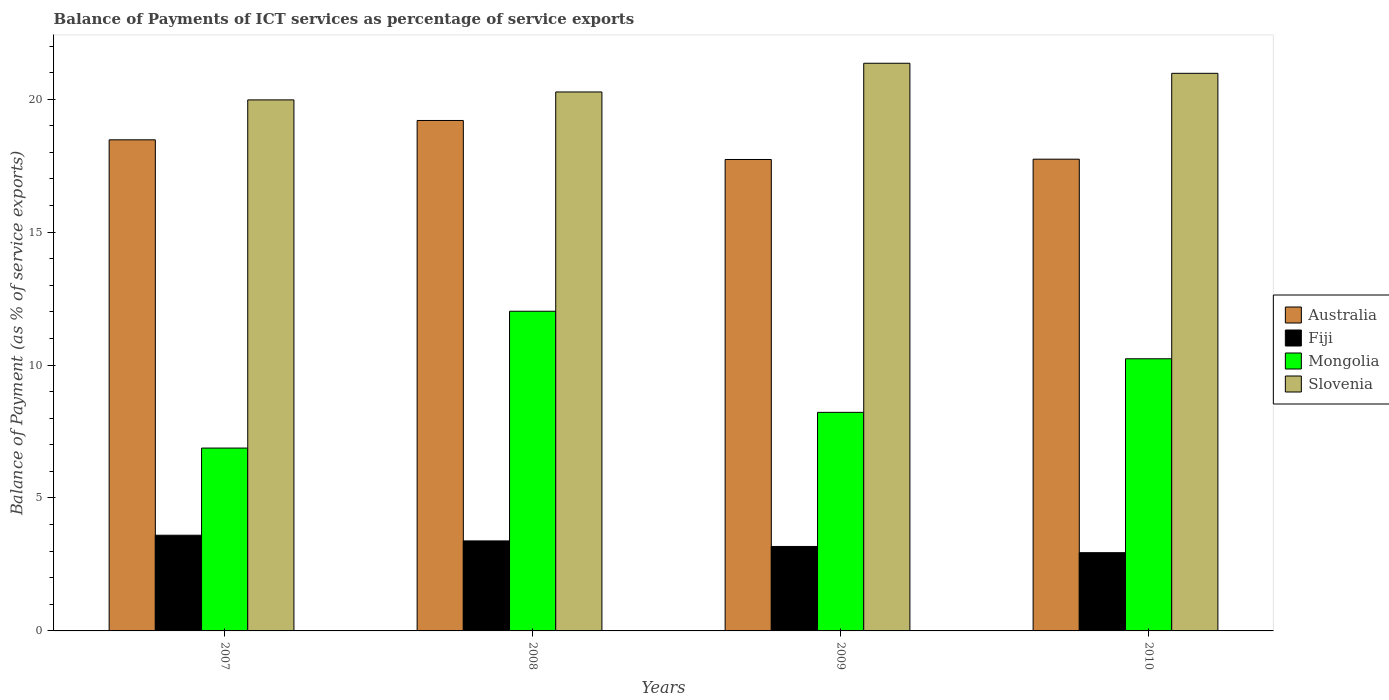How many different coloured bars are there?
Offer a very short reply. 4. Are the number of bars on each tick of the X-axis equal?
Your answer should be very brief. Yes. How many bars are there on the 2nd tick from the left?
Give a very brief answer. 4. How many bars are there on the 2nd tick from the right?
Provide a short and direct response. 4. In how many cases, is the number of bars for a given year not equal to the number of legend labels?
Make the answer very short. 0. What is the balance of payments of ICT services in Fiji in 2010?
Your answer should be very brief. 2.94. Across all years, what is the maximum balance of payments of ICT services in Slovenia?
Keep it short and to the point. 21.35. Across all years, what is the minimum balance of payments of ICT services in Slovenia?
Keep it short and to the point. 19.97. In which year was the balance of payments of ICT services in Australia maximum?
Offer a very short reply. 2008. What is the total balance of payments of ICT services in Mongolia in the graph?
Keep it short and to the point. 37.36. What is the difference between the balance of payments of ICT services in Fiji in 2007 and that in 2010?
Offer a terse response. 0.66. What is the difference between the balance of payments of ICT services in Slovenia in 2008 and the balance of payments of ICT services in Australia in 2010?
Provide a short and direct response. 2.53. What is the average balance of payments of ICT services in Fiji per year?
Your answer should be very brief. 3.28. In the year 2010, what is the difference between the balance of payments of ICT services in Australia and balance of payments of ICT services in Mongolia?
Offer a terse response. 7.51. What is the ratio of the balance of payments of ICT services in Mongolia in 2008 to that in 2010?
Give a very brief answer. 1.17. What is the difference between the highest and the second highest balance of payments of ICT services in Slovenia?
Provide a short and direct response. 0.38. What is the difference between the highest and the lowest balance of payments of ICT services in Fiji?
Offer a very short reply. 0.66. Is the sum of the balance of payments of ICT services in Mongolia in 2008 and 2009 greater than the maximum balance of payments of ICT services in Fiji across all years?
Offer a terse response. Yes. Is it the case that in every year, the sum of the balance of payments of ICT services in Mongolia and balance of payments of ICT services in Fiji is greater than the sum of balance of payments of ICT services in Australia and balance of payments of ICT services in Slovenia?
Offer a terse response. No. What does the 2nd bar from the left in 2007 represents?
Make the answer very short. Fiji. What does the 3rd bar from the right in 2010 represents?
Provide a short and direct response. Fiji. Is it the case that in every year, the sum of the balance of payments of ICT services in Slovenia and balance of payments of ICT services in Fiji is greater than the balance of payments of ICT services in Australia?
Your answer should be very brief. Yes. Are all the bars in the graph horizontal?
Give a very brief answer. No. Does the graph contain any zero values?
Keep it short and to the point. No. What is the title of the graph?
Provide a succinct answer. Balance of Payments of ICT services as percentage of service exports. Does "Afghanistan" appear as one of the legend labels in the graph?
Offer a terse response. No. What is the label or title of the X-axis?
Make the answer very short. Years. What is the label or title of the Y-axis?
Ensure brevity in your answer.  Balance of Payment (as % of service exports). What is the Balance of Payment (as % of service exports) in Australia in 2007?
Keep it short and to the point. 18.47. What is the Balance of Payment (as % of service exports) in Fiji in 2007?
Keep it short and to the point. 3.6. What is the Balance of Payment (as % of service exports) of Mongolia in 2007?
Provide a short and direct response. 6.88. What is the Balance of Payment (as % of service exports) of Slovenia in 2007?
Keep it short and to the point. 19.97. What is the Balance of Payment (as % of service exports) in Australia in 2008?
Offer a terse response. 19.2. What is the Balance of Payment (as % of service exports) in Fiji in 2008?
Keep it short and to the point. 3.39. What is the Balance of Payment (as % of service exports) in Mongolia in 2008?
Your answer should be compact. 12.02. What is the Balance of Payment (as % of service exports) of Slovenia in 2008?
Provide a succinct answer. 20.27. What is the Balance of Payment (as % of service exports) of Australia in 2009?
Your answer should be compact. 17.73. What is the Balance of Payment (as % of service exports) of Fiji in 2009?
Offer a terse response. 3.18. What is the Balance of Payment (as % of service exports) in Mongolia in 2009?
Your response must be concise. 8.22. What is the Balance of Payment (as % of service exports) in Slovenia in 2009?
Provide a short and direct response. 21.35. What is the Balance of Payment (as % of service exports) in Australia in 2010?
Your answer should be compact. 17.74. What is the Balance of Payment (as % of service exports) of Fiji in 2010?
Give a very brief answer. 2.94. What is the Balance of Payment (as % of service exports) of Mongolia in 2010?
Your response must be concise. 10.24. What is the Balance of Payment (as % of service exports) of Slovenia in 2010?
Ensure brevity in your answer.  20.97. Across all years, what is the maximum Balance of Payment (as % of service exports) in Australia?
Make the answer very short. 19.2. Across all years, what is the maximum Balance of Payment (as % of service exports) of Fiji?
Offer a terse response. 3.6. Across all years, what is the maximum Balance of Payment (as % of service exports) in Mongolia?
Offer a terse response. 12.02. Across all years, what is the maximum Balance of Payment (as % of service exports) of Slovenia?
Your response must be concise. 21.35. Across all years, what is the minimum Balance of Payment (as % of service exports) in Australia?
Offer a terse response. 17.73. Across all years, what is the minimum Balance of Payment (as % of service exports) in Fiji?
Ensure brevity in your answer.  2.94. Across all years, what is the minimum Balance of Payment (as % of service exports) in Mongolia?
Provide a succinct answer. 6.88. Across all years, what is the minimum Balance of Payment (as % of service exports) of Slovenia?
Ensure brevity in your answer.  19.97. What is the total Balance of Payment (as % of service exports) of Australia in the graph?
Keep it short and to the point. 73.15. What is the total Balance of Payment (as % of service exports) in Fiji in the graph?
Provide a short and direct response. 13.1. What is the total Balance of Payment (as % of service exports) of Mongolia in the graph?
Give a very brief answer. 37.36. What is the total Balance of Payment (as % of service exports) of Slovenia in the graph?
Offer a terse response. 82.57. What is the difference between the Balance of Payment (as % of service exports) in Australia in 2007 and that in 2008?
Your answer should be very brief. -0.73. What is the difference between the Balance of Payment (as % of service exports) in Fiji in 2007 and that in 2008?
Your response must be concise. 0.21. What is the difference between the Balance of Payment (as % of service exports) in Mongolia in 2007 and that in 2008?
Provide a short and direct response. -5.15. What is the difference between the Balance of Payment (as % of service exports) in Slovenia in 2007 and that in 2008?
Your answer should be very brief. -0.3. What is the difference between the Balance of Payment (as % of service exports) of Australia in 2007 and that in 2009?
Your answer should be very brief. 0.74. What is the difference between the Balance of Payment (as % of service exports) in Fiji in 2007 and that in 2009?
Offer a very short reply. 0.42. What is the difference between the Balance of Payment (as % of service exports) in Mongolia in 2007 and that in 2009?
Offer a terse response. -1.34. What is the difference between the Balance of Payment (as % of service exports) in Slovenia in 2007 and that in 2009?
Your answer should be very brief. -1.38. What is the difference between the Balance of Payment (as % of service exports) in Australia in 2007 and that in 2010?
Keep it short and to the point. 0.73. What is the difference between the Balance of Payment (as % of service exports) in Fiji in 2007 and that in 2010?
Provide a short and direct response. 0.66. What is the difference between the Balance of Payment (as % of service exports) in Mongolia in 2007 and that in 2010?
Provide a short and direct response. -3.36. What is the difference between the Balance of Payment (as % of service exports) of Slovenia in 2007 and that in 2010?
Make the answer very short. -1. What is the difference between the Balance of Payment (as % of service exports) of Australia in 2008 and that in 2009?
Offer a terse response. 1.47. What is the difference between the Balance of Payment (as % of service exports) in Fiji in 2008 and that in 2009?
Your answer should be very brief. 0.21. What is the difference between the Balance of Payment (as % of service exports) of Mongolia in 2008 and that in 2009?
Ensure brevity in your answer.  3.8. What is the difference between the Balance of Payment (as % of service exports) of Slovenia in 2008 and that in 2009?
Keep it short and to the point. -1.08. What is the difference between the Balance of Payment (as % of service exports) of Australia in 2008 and that in 2010?
Offer a very short reply. 1.46. What is the difference between the Balance of Payment (as % of service exports) in Fiji in 2008 and that in 2010?
Provide a short and direct response. 0.44. What is the difference between the Balance of Payment (as % of service exports) in Mongolia in 2008 and that in 2010?
Your answer should be very brief. 1.79. What is the difference between the Balance of Payment (as % of service exports) in Slovenia in 2008 and that in 2010?
Provide a succinct answer. -0.7. What is the difference between the Balance of Payment (as % of service exports) of Australia in 2009 and that in 2010?
Your answer should be very brief. -0.01. What is the difference between the Balance of Payment (as % of service exports) in Fiji in 2009 and that in 2010?
Provide a short and direct response. 0.23. What is the difference between the Balance of Payment (as % of service exports) of Mongolia in 2009 and that in 2010?
Offer a terse response. -2.02. What is the difference between the Balance of Payment (as % of service exports) in Slovenia in 2009 and that in 2010?
Provide a succinct answer. 0.38. What is the difference between the Balance of Payment (as % of service exports) of Australia in 2007 and the Balance of Payment (as % of service exports) of Fiji in 2008?
Provide a short and direct response. 15.09. What is the difference between the Balance of Payment (as % of service exports) in Australia in 2007 and the Balance of Payment (as % of service exports) in Mongolia in 2008?
Your response must be concise. 6.45. What is the difference between the Balance of Payment (as % of service exports) in Australia in 2007 and the Balance of Payment (as % of service exports) in Slovenia in 2008?
Ensure brevity in your answer.  -1.8. What is the difference between the Balance of Payment (as % of service exports) in Fiji in 2007 and the Balance of Payment (as % of service exports) in Mongolia in 2008?
Give a very brief answer. -8.43. What is the difference between the Balance of Payment (as % of service exports) in Fiji in 2007 and the Balance of Payment (as % of service exports) in Slovenia in 2008?
Your answer should be compact. -16.67. What is the difference between the Balance of Payment (as % of service exports) of Mongolia in 2007 and the Balance of Payment (as % of service exports) of Slovenia in 2008?
Provide a succinct answer. -13.39. What is the difference between the Balance of Payment (as % of service exports) in Australia in 2007 and the Balance of Payment (as % of service exports) in Fiji in 2009?
Provide a short and direct response. 15.29. What is the difference between the Balance of Payment (as % of service exports) of Australia in 2007 and the Balance of Payment (as % of service exports) of Mongolia in 2009?
Ensure brevity in your answer.  10.25. What is the difference between the Balance of Payment (as % of service exports) in Australia in 2007 and the Balance of Payment (as % of service exports) in Slovenia in 2009?
Offer a very short reply. -2.88. What is the difference between the Balance of Payment (as % of service exports) of Fiji in 2007 and the Balance of Payment (as % of service exports) of Mongolia in 2009?
Your answer should be compact. -4.62. What is the difference between the Balance of Payment (as % of service exports) in Fiji in 2007 and the Balance of Payment (as % of service exports) in Slovenia in 2009?
Keep it short and to the point. -17.75. What is the difference between the Balance of Payment (as % of service exports) in Mongolia in 2007 and the Balance of Payment (as % of service exports) in Slovenia in 2009?
Offer a terse response. -14.47. What is the difference between the Balance of Payment (as % of service exports) in Australia in 2007 and the Balance of Payment (as % of service exports) in Fiji in 2010?
Ensure brevity in your answer.  15.53. What is the difference between the Balance of Payment (as % of service exports) of Australia in 2007 and the Balance of Payment (as % of service exports) of Mongolia in 2010?
Ensure brevity in your answer.  8.24. What is the difference between the Balance of Payment (as % of service exports) of Australia in 2007 and the Balance of Payment (as % of service exports) of Slovenia in 2010?
Your response must be concise. -2.5. What is the difference between the Balance of Payment (as % of service exports) of Fiji in 2007 and the Balance of Payment (as % of service exports) of Mongolia in 2010?
Keep it short and to the point. -6.64. What is the difference between the Balance of Payment (as % of service exports) in Fiji in 2007 and the Balance of Payment (as % of service exports) in Slovenia in 2010?
Offer a very short reply. -17.37. What is the difference between the Balance of Payment (as % of service exports) of Mongolia in 2007 and the Balance of Payment (as % of service exports) of Slovenia in 2010?
Offer a very short reply. -14.1. What is the difference between the Balance of Payment (as % of service exports) in Australia in 2008 and the Balance of Payment (as % of service exports) in Fiji in 2009?
Provide a short and direct response. 16.02. What is the difference between the Balance of Payment (as % of service exports) in Australia in 2008 and the Balance of Payment (as % of service exports) in Mongolia in 2009?
Your answer should be very brief. 10.98. What is the difference between the Balance of Payment (as % of service exports) in Australia in 2008 and the Balance of Payment (as % of service exports) in Slovenia in 2009?
Ensure brevity in your answer.  -2.15. What is the difference between the Balance of Payment (as % of service exports) in Fiji in 2008 and the Balance of Payment (as % of service exports) in Mongolia in 2009?
Give a very brief answer. -4.84. What is the difference between the Balance of Payment (as % of service exports) in Fiji in 2008 and the Balance of Payment (as % of service exports) in Slovenia in 2009?
Ensure brevity in your answer.  -17.97. What is the difference between the Balance of Payment (as % of service exports) in Mongolia in 2008 and the Balance of Payment (as % of service exports) in Slovenia in 2009?
Keep it short and to the point. -9.33. What is the difference between the Balance of Payment (as % of service exports) of Australia in 2008 and the Balance of Payment (as % of service exports) of Fiji in 2010?
Give a very brief answer. 16.26. What is the difference between the Balance of Payment (as % of service exports) in Australia in 2008 and the Balance of Payment (as % of service exports) in Mongolia in 2010?
Make the answer very short. 8.96. What is the difference between the Balance of Payment (as % of service exports) of Australia in 2008 and the Balance of Payment (as % of service exports) of Slovenia in 2010?
Make the answer very short. -1.77. What is the difference between the Balance of Payment (as % of service exports) in Fiji in 2008 and the Balance of Payment (as % of service exports) in Mongolia in 2010?
Your answer should be very brief. -6.85. What is the difference between the Balance of Payment (as % of service exports) in Fiji in 2008 and the Balance of Payment (as % of service exports) in Slovenia in 2010?
Your answer should be very brief. -17.59. What is the difference between the Balance of Payment (as % of service exports) in Mongolia in 2008 and the Balance of Payment (as % of service exports) in Slovenia in 2010?
Ensure brevity in your answer.  -8.95. What is the difference between the Balance of Payment (as % of service exports) in Australia in 2009 and the Balance of Payment (as % of service exports) in Fiji in 2010?
Give a very brief answer. 14.79. What is the difference between the Balance of Payment (as % of service exports) in Australia in 2009 and the Balance of Payment (as % of service exports) in Mongolia in 2010?
Provide a succinct answer. 7.5. What is the difference between the Balance of Payment (as % of service exports) of Australia in 2009 and the Balance of Payment (as % of service exports) of Slovenia in 2010?
Your response must be concise. -3.24. What is the difference between the Balance of Payment (as % of service exports) in Fiji in 2009 and the Balance of Payment (as % of service exports) in Mongolia in 2010?
Your answer should be very brief. -7.06. What is the difference between the Balance of Payment (as % of service exports) in Fiji in 2009 and the Balance of Payment (as % of service exports) in Slovenia in 2010?
Keep it short and to the point. -17.8. What is the difference between the Balance of Payment (as % of service exports) in Mongolia in 2009 and the Balance of Payment (as % of service exports) in Slovenia in 2010?
Give a very brief answer. -12.75. What is the average Balance of Payment (as % of service exports) of Australia per year?
Provide a short and direct response. 18.29. What is the average Balance of Payment (as % of service exports) in Fiji per year?
Keep it short and to the point. 3.28. What is the average Balance of Payment (as % of service exports) in Mongolia per year?
Ensure brevity in your answer.  9.34. What is the average Balance of Payment (as % of service exports) in Slovenia per year?
Offer a very short reply. 20.64. In the year 2007, what is the difference between the Balance of Payment (as % of service exports) of Australia and Balance of Payment (as % of service exports) of Fiji?
Offer a very short reply. 14.87. In the year 2007, what is the difference between the Balance of Payment (as % of service exports) of Australia and Balance of Payment (as % of service exports) of Mongolia?
Keep it short and to the point. 11.59. In the year 2007, what is the difference between the Balance of Payment (as % of service exports) of Australia and Balance of Payment (as % of service exports) of Slovenia?
Offer a very short reply. -1.5. In the year 2007, what is the difference between the Balance of Payment (as % of service exports) in Fiji and Balance of Payment (as % of service exports) in Mongolia?
Make the answer very short. -3.28. In the year 2007, what is the difference between the Balance of Payment (as % of service exports) in Fiji and Balance of Payment (as % of service exports) in Slovenia?
Offer a very short reply. -16.37. In the year 2007, what is the difference between the Balance of Payment (as % of service exports) in Mongolia and Balance of Payment (as % of service exports) in Slovenia?
Give a very brief answer. -13.1. In the year 2008, what is the difference between the Balance of Payment (as % of service exports) of Australia and Balance of Payment (as % of service exports) of Fiji?
Give a very brief answer. 15.81. In the year 2008, what is the difference between the Balance of Payment (as % of service exports) in Australia and Balance of Payment (as % of service exports) in Mongolia?
Your response must be concise. 7.18. In the year 2008, what is the difference between the Balance of Payment (as % of service exports) in Australia and Balance of Payment (as % of service exports) in Slovenia?
Give a very brief answer. -1.07. In the year 2008, what is the difference between the Balance of Payment (as % of service exports) of Fiji and Balance of Payment (as % of service exports) of Mongolia?
Provide a succinct answer. -8.64. In the year 2008, what is the difference between the Balance of Payment (as % of service exports) in Fiji and Balance of Payment (as % of service exports) in Slovenia?
Your answer should be compact. -16.89. In the year 2008, what is the difference between the Balance of Payment (as % of service exports) in Mongolia and Balance of Payment (as % of service exports) in Slovenia?
Keep it short and to the point. -8.25. In the year 2009, what is the difference between the Balance of Payment (as % of service exports) of Australia and Balance of Payment (as % of service exports) of Fiji?
Make the answer very short. 14.56. In the year 2009, what is the difference between the Balance of Payment (as % of service exports) of Australia and Balance of Payment (as % of service exports) of Mongolia?
Ensure brevity in your answer.  9.51. In the year 2009, what is the difference between the Balance of Payment (as % of service exports) in Australia and Balance of Payment (as % of service exports) in Slovenia?
Offer a very short reply. -3.62. In the year 2009, what is the difference between the Balance of Payment (as % of service exports) of Fiji and Balance of Payment (as % of service exports) of Mongolia?
Provide a short and direct response. -5.04. In the year 2009, what is the difference between the Balance of Payment (as % of service exports) of Fiji and Balance of Payment (as % of service exports) of Slovenia?
Your response must be concise. -18.17. In the year 2009, what is the difference between the Balance of Payment (as % of service exports) in Mongolia and Balance of Payment (as % of service exports) in Slovenia?
Your answer should be compact. -13.13. In the year 2010, what is the difference between the Balance of Payment (as % of service exports) of Australia and Balance of Payment (as % of service exports) of Fiji?
Your response must be concise. 14.8. In the year 2010, what is the difference between the Balance of Payment (as % of service exports) in Australia and Balance of Payment (as % of service exports) in Mongolia?
Keep it short and to the point. 7.51. In the year 2010, what is the difference between the Balance of Payment (as % of service exports) in Australia and Balance of Payment (as % of service exports) in Slovenia?
Offer a very short reply. -3.23. In the year 2010, what is the difference between the Balance of Payment (as % of service exports) of Fiji and Balance of Payment (as % of service exports) of Mongolia?
Offer a very short reply. -7.29. In the year 2010, what is the difference between the Balance of Payment (as % of service exports) of Fiji and Balance of Payment (as % of service exports) of Slovenia?
Give a very brief answer. -18.03. In the year 2010, what is the difference between the Balance of Payment (as % of service exports) in Mongolia and Balance of Payment (as % of service exports) in Slovenia?
Offer a very short reply. -10.74. What is the ratio of the Balance of Payment (as % of service exports) in Australia in 2007 to that in 2008?
Offer a terse response. 0.96. What is the ratio of the Balance of Payment (as % of service exports) in Fiji in 2007 to that in 2008?
Your answer should be compact. 1.06. What is the ratio of the Balance of Payment (as % of service exports) in Mongolia in 2007 to that in 2008?
Give a very brief answer. 0.57. What is the ratio of the Balance of Payment (as % of service exports) of Australia in 2007 to that in 2009?
Provide a succinct answer. 1.04. What is the ratio of the Balance of Payment (as % of service exports) in Fiji in 2007 to that in 2009?
Give a very brief answer. 1.13. What is the ratio of the Balance of Payment (as % of service exports) of Mongolia in 2007 to that in 2009?
Make the answer very short. 0.84. What is the ratio of the Balance of Payment (as % of service exports) of Slovenia in 2007 to that in 2009?
Provide a short and direct response. 0.94. What is the ratio of the Balance of Payment (as % of service exports) in Australia in 2007 to that in 2010?
Ensure brevity in your answer.  1.04. What is the ratio of the Balance of Payment (as % of service exports) in Fiji in 2007 to that in 2010?
Your response must be concise. 1.22. What is the ratio of the Balance of Payment (as % of service exports) of Mongolia in 2007 to that in 2010?
Offer a very short reply. 0.67. What is the ratio of the Balance of Payment (as % of service exports) in Slovenia in 2007 to that in 2010?
Your answer should be compact. 0.95. What is the ratio of the Balance of Payment (as % of service exports) in Australia in 2008 to that in 2009?
Make the answer very short. 1.08. What is the ratio of the Balance of Payment (as % of service exports) of Fiji in 2008 to that in 2009?
Make the answer very short. 1.07. What is the ratio of the Balance of Payment (as % of service exports) in Mongolia in 2008 to that in 2009?
Offer a very short reply. 1.46. What is the ratio of the Balance of Payment (as % of service exports) in Slovenia in 2008 to that in 2009?
Offer a very short reply. 0.95. What is the ratio of the Balance of Payment (as % of service exports) of Australia in 2008 to that in 2010?
Make the answer very short. 1.08. What is the ratio of the Balance of Payment (as % of service exports) in Fiji in 2008 to that in 2010?
Provide a short and direct response. 1.15. What is the ratio of the Balance of Payment (as % of service exports) of Mongolia in 2008 to that in 2010?
Provide a succinct answer. 1.17. What is the ratio of the Balance of Payment (as % of service exports) of Slovenia in 2008 to that in 2010?
Your response must be concise. 0.97. What is the ratio of the Balance of Payment (as % of service exports) of Fiji in 2009 to that in 2010?
Provide a succinct answer. 1.08. What is the ratio of the Balance of Payment (as % of service exports) of Mongolia in 2009 to that in 2010?
Make the answer very short. 0.8. What is the ratio of the Balance of Payment (as % of service exports) of Slovenia in 2009 to that in 2010?
Your answer should be very brief. 1.02. What is the difference between the highest and the second highest Balance of Payment (as % of service exports) in Australia?
Your answer should be compact. 0.73. What is the difference between the highest and the second highest Balance of Payment (as % of service exports) in Fiji?
Give a very brief answer. 0.21. What is the difference between the highest and the second highest Balance of Payment (as % of service exports) in Mongolia?
Your answer should be very brief. 1.79. What is the difference between the highest and the second highest Balance of Payment (as % of service exports) in Slovenia?
Your answer should be very brief. 0.38. What is the difference between the highest and the lowest Balance of Payment (as % of service exports) of Australia?
Your response must be concise. 1.47. What is the difference between the highest and the lowest Balance of Payment (as % of service exports) of Fiji?
Your answer should be compact. 0.66. What is the difference between the highest and the lowest Balance of Payment (as % of service exports) of Mongolia?
Your answer should be very brief. 5.15. What is the difference between the highest and the lowest Balance of Payment (as % of service exports) in Slovenia?
Your answer should be very brief. 1.38. 